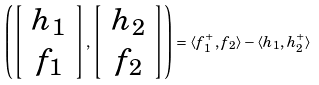Convert formula to latex. <formula><loc_0><loc_0><loc_500><loc_500>\left ( \left [ \begin{array} { c } h _ { 1 } \\ f _ { 1 } \end{array} \right ] , \left [ \begin{array} { c } h _ { 2 } \\ f _ { 2 } \end{array} \right ] \right ) = \langle f _ { 1 } ^ { + } , f _ { 2 } \rangle - \langle h _ { 1 } , h _ { 2 } ^ { + } \rangle</formula> 